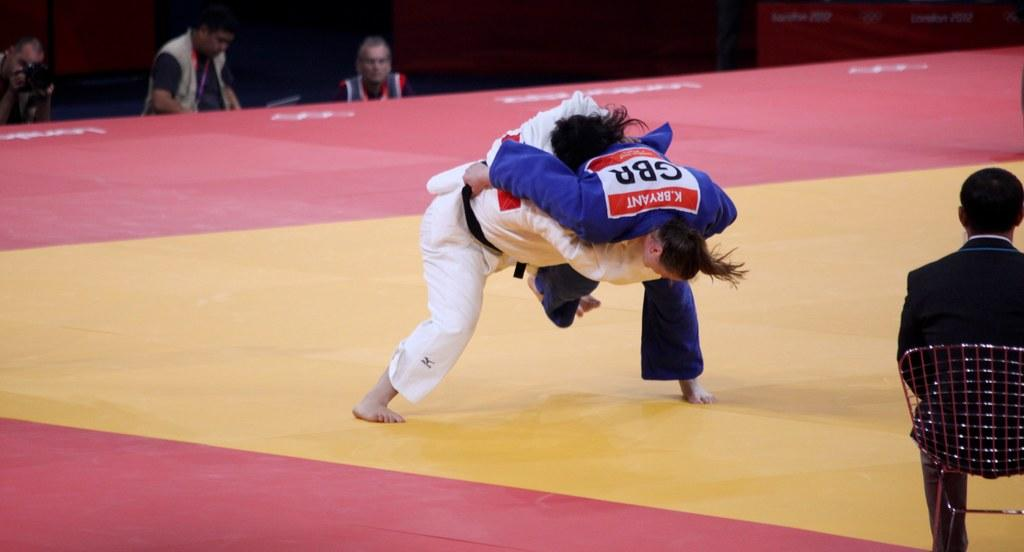<image>
Summarize the visual content of the image. a couple of wrestlers with one wearing GBR on themselves 